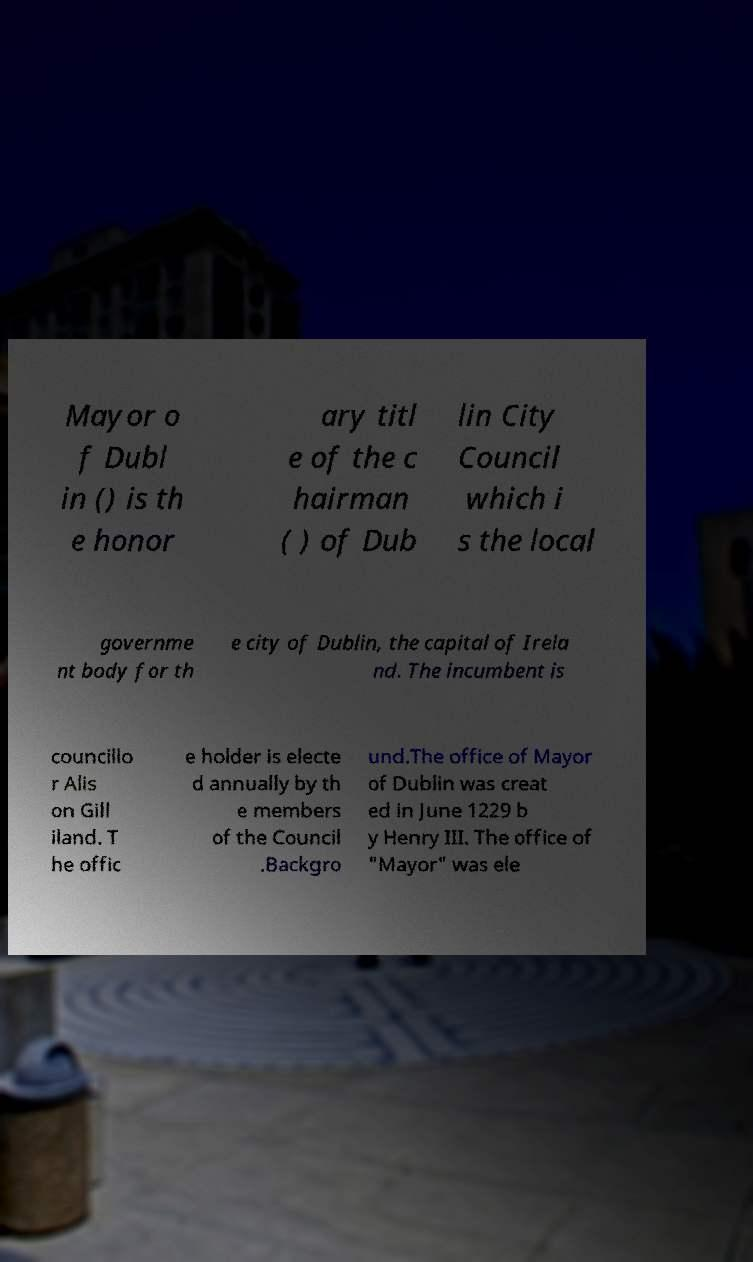I need the written content from this picture converted into text. Can you do that? Mayor o f Dubl in () is th e honor ary titl e of the c hairman ( ) of Dub lin City Council which i s the local governme nt body for th e city of Dublin, the capital of Irela nd. The incumbent is councillo r Alis on Gill iland. T he offic e holder is electe d annually by th e members of the Council .Backgro und.The office of Mayor of Dublin was creat ed in June 1229 b y Henry III. The office of "Mayor" was ele 